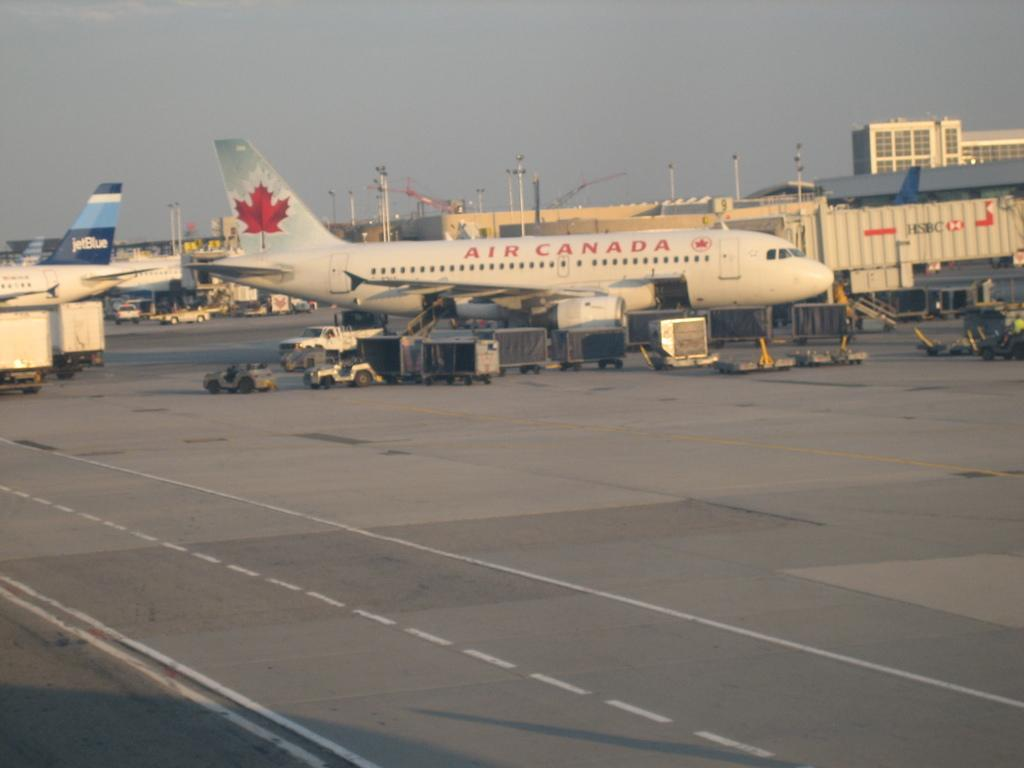What type of vehicles can be seen on the road in the image? There are aircrafts on the road in the image. What else can be seen in the image besides the aircrafts? There are fleets of vehicles in the image. What is visible in the background of the image? There are buildings, light poles, and the sky visible in the background of the image. Can you determine the time of day the image was taken? The image might have been taken during the day, as the sky is visible. What type of sand can be seen on the police vehicles in the image? There are no police vehicles or sand present in the image. 